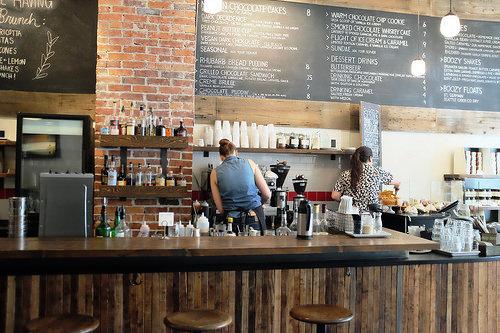<image>
Is the cup on the table? No. The cup is not positioned on the table. They may be near each other, but the cup is not supported by or resting on top of the table. Is the bottle on the table? No. The bottle is not positioned on the table. They may be near each other, but the bottle is not supported by or resting on top of the table. 